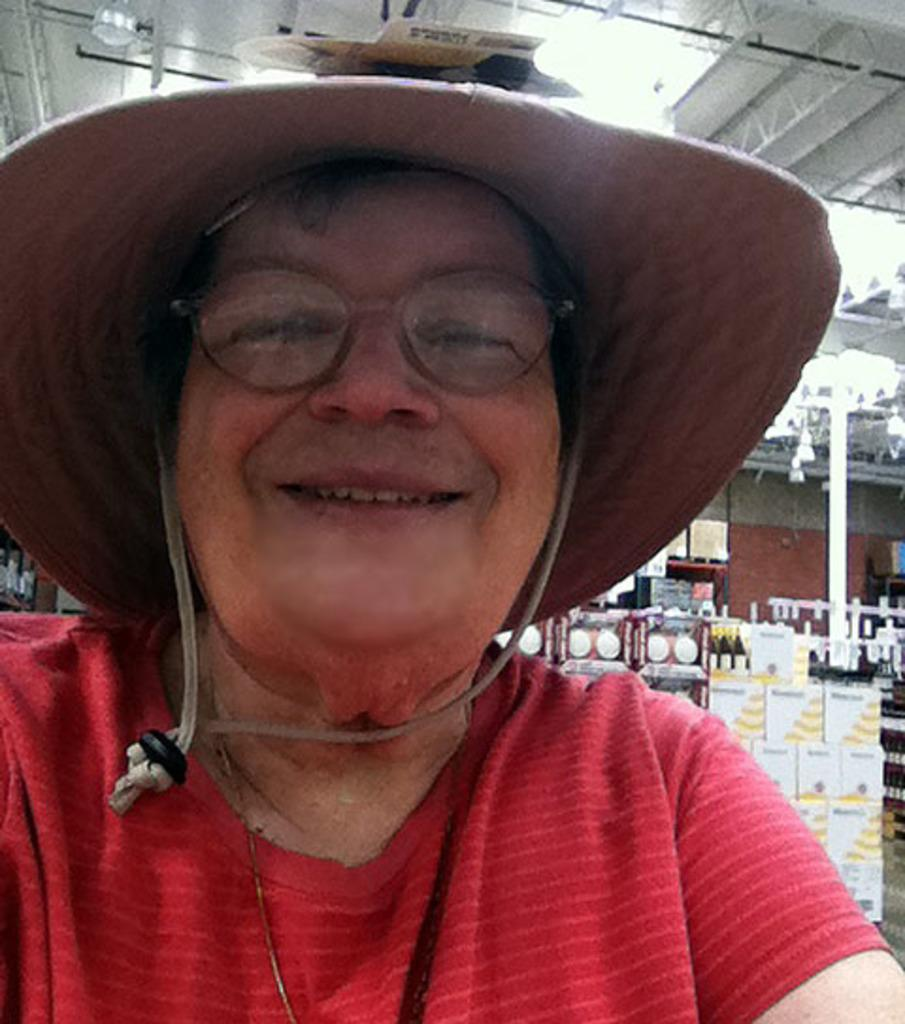Who is the main subject in the image? There is a woman in the image. What is the woman wearing on her head? The woman is wearing a hat. What can be seen behind the woman in the image? There are other objects behind the woman. What type of lighting is present on the roof? There are white color lights on the roof. How much wealth does the woman in the image possess? There is no information about the woman's wealth in the image. Does the woman in the image have the ability to spark a fire with her hat? There is no indication of any spark-related abilities or objects in the image. 